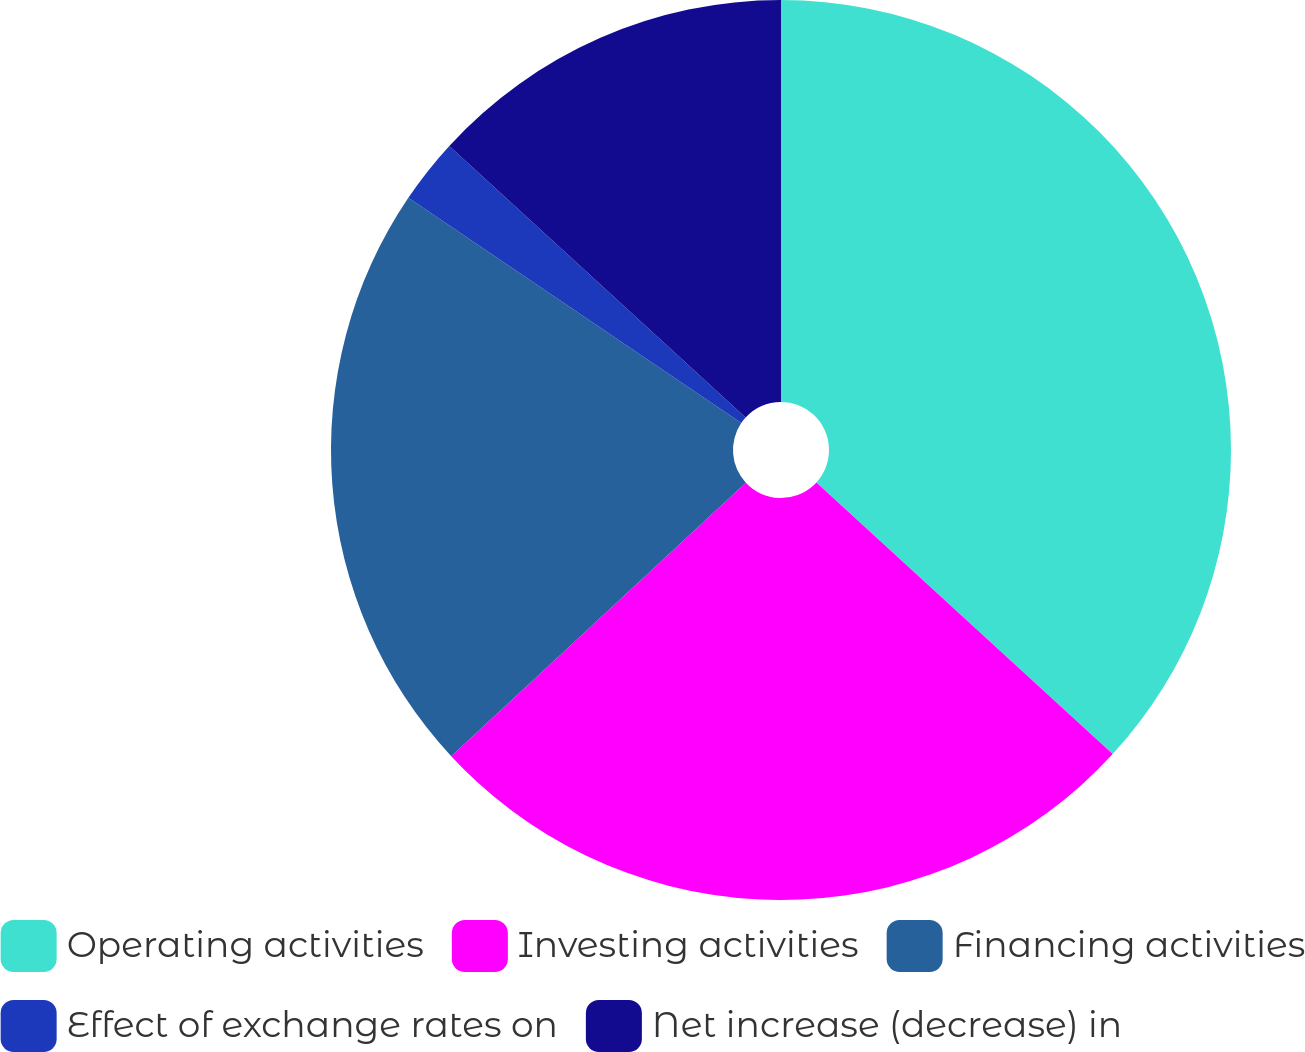<chart> <loc_0><loc_0><loc_500><loc_500><pie_chart><fcel>Operating activities<fcel>Investing activities<fcel>Financing activities<fcel>Effect of exchange rates on<fcel>Net increase (decrease) in<nl><fcel>36.81%<fcel>26.28%<fcel>21.38%<fcel>2.34%<fcel>13.19%<nl></chart> 